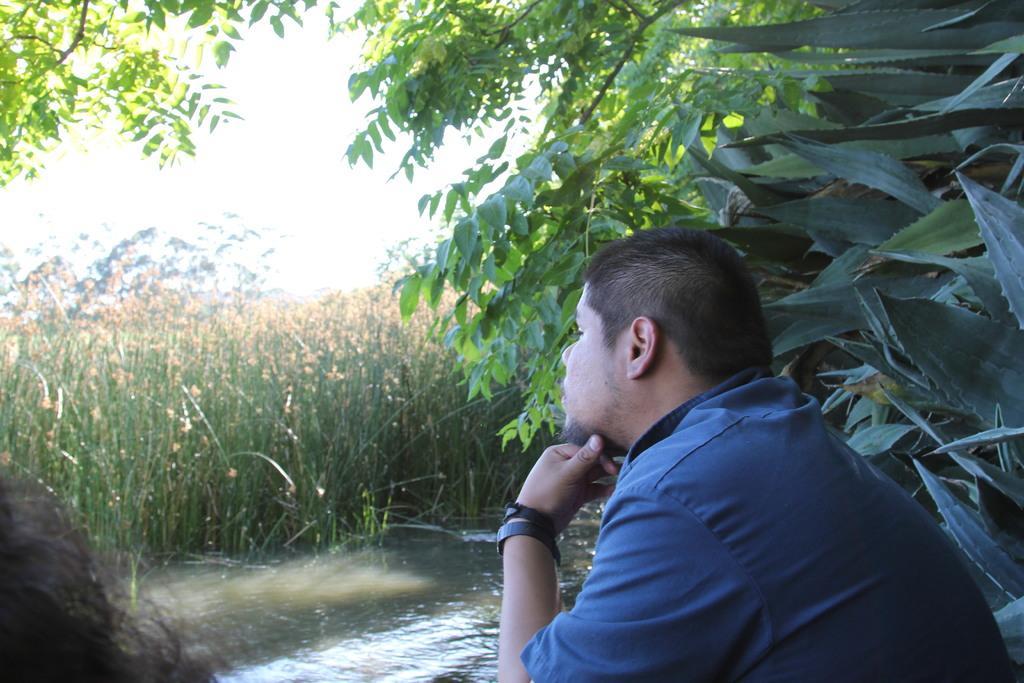Could you give a brief overview of what you see in this image? In this image I can see two persons, water, plants, trees and the sky. This image is taken may be near the lake. 